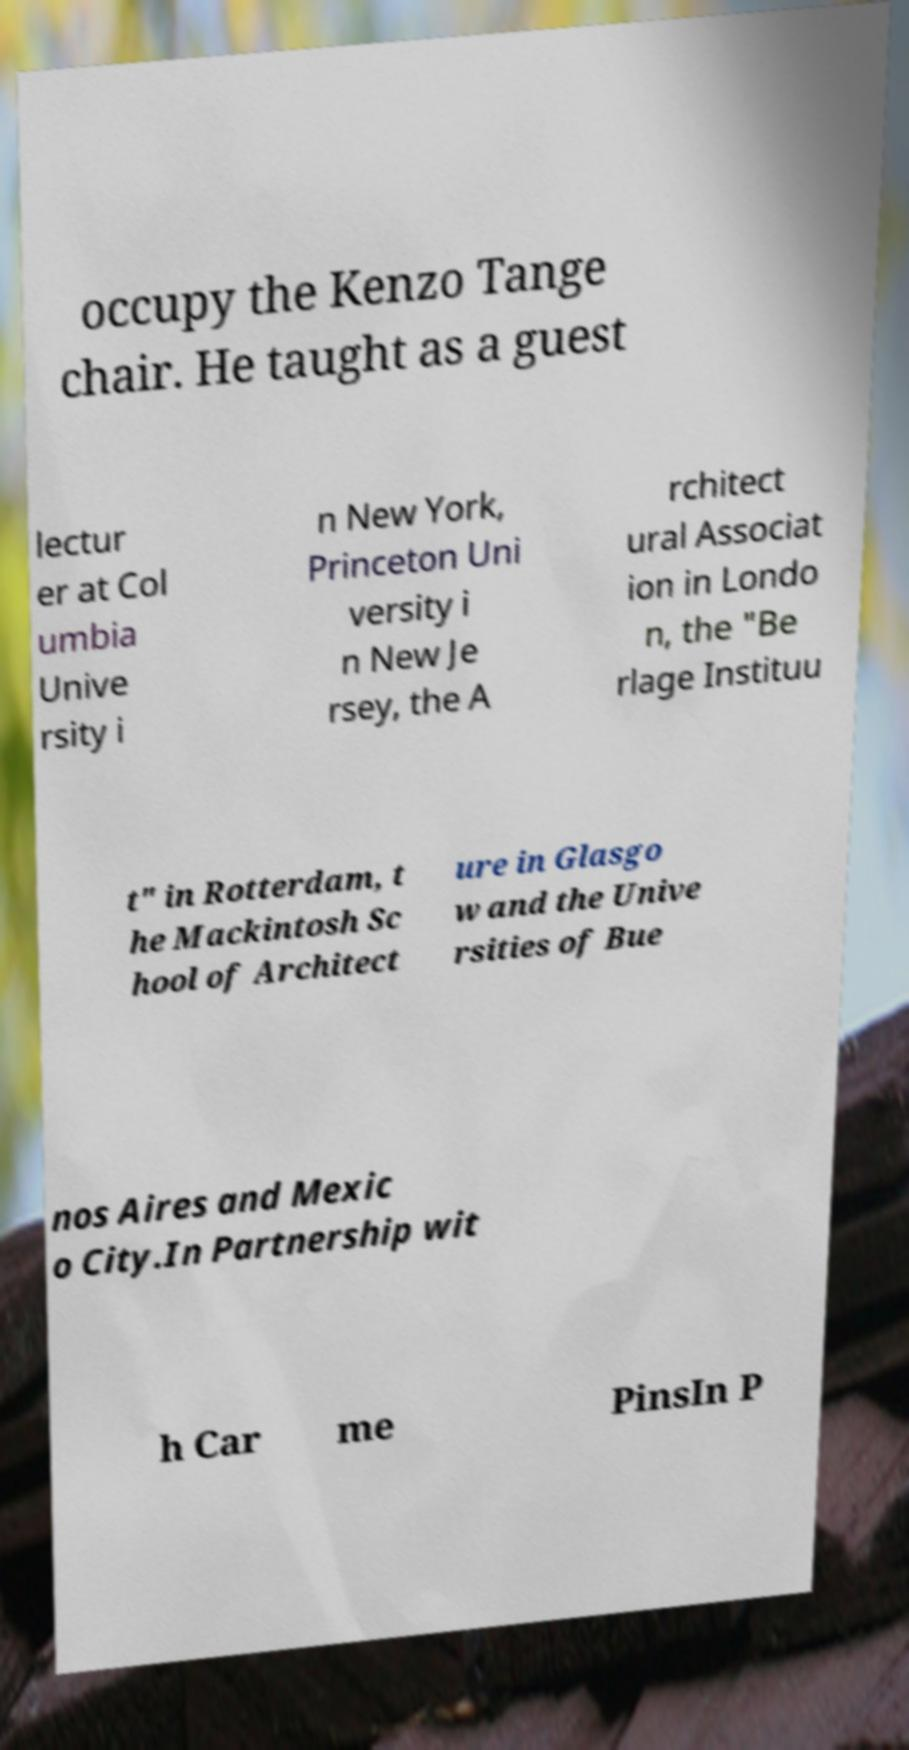I need the written content from this picture converted into text. Can you do that? occupy the Kenzo Tange chair. He taught as a guest lectur er at Col umbia Unive rsity i n New York, Princeton Uni versity i n New Je rsey, the A rchitect ural Associat ion in Londo n, the "Be rlage Instituu t" in Rotterdam, t he Mackintosh Sc hool of Architect ure in Glasgo w and the Unive rsities of Bue nos Aires and Mexic o City.In Partnership wit h Car me PinsIn P 